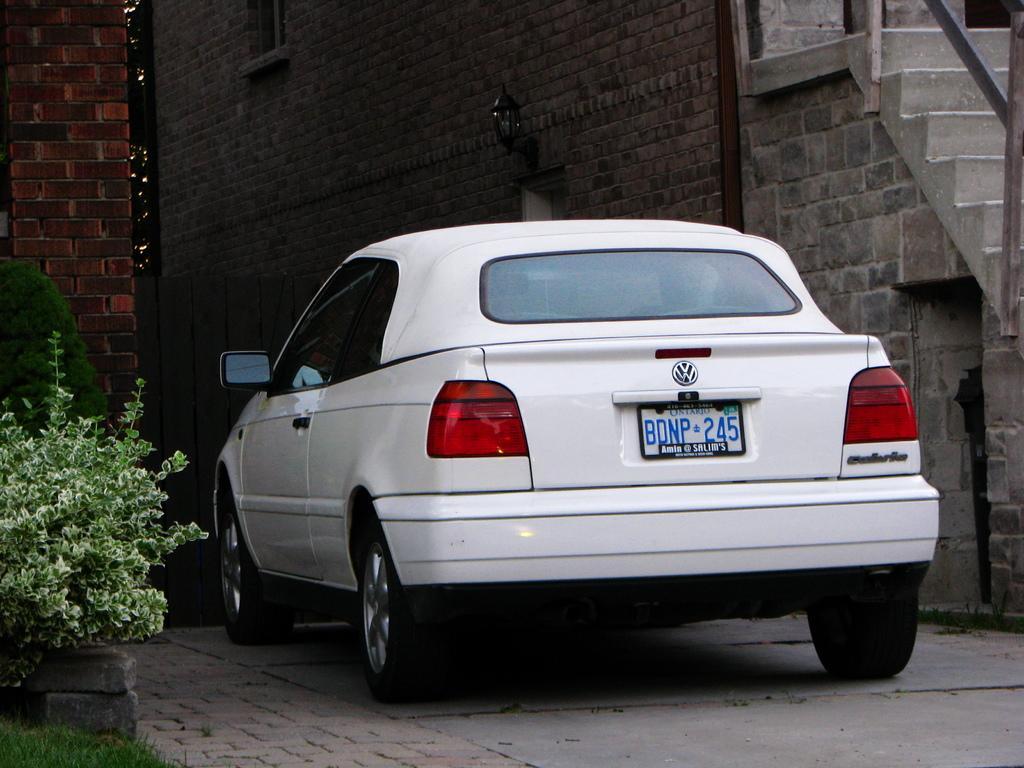Please provide a concise description of this image. In this image there is a car parked, in front of the car there is a wooden door. On the right and left side of the image there are buildings, in front of the building there are trees and plants. 